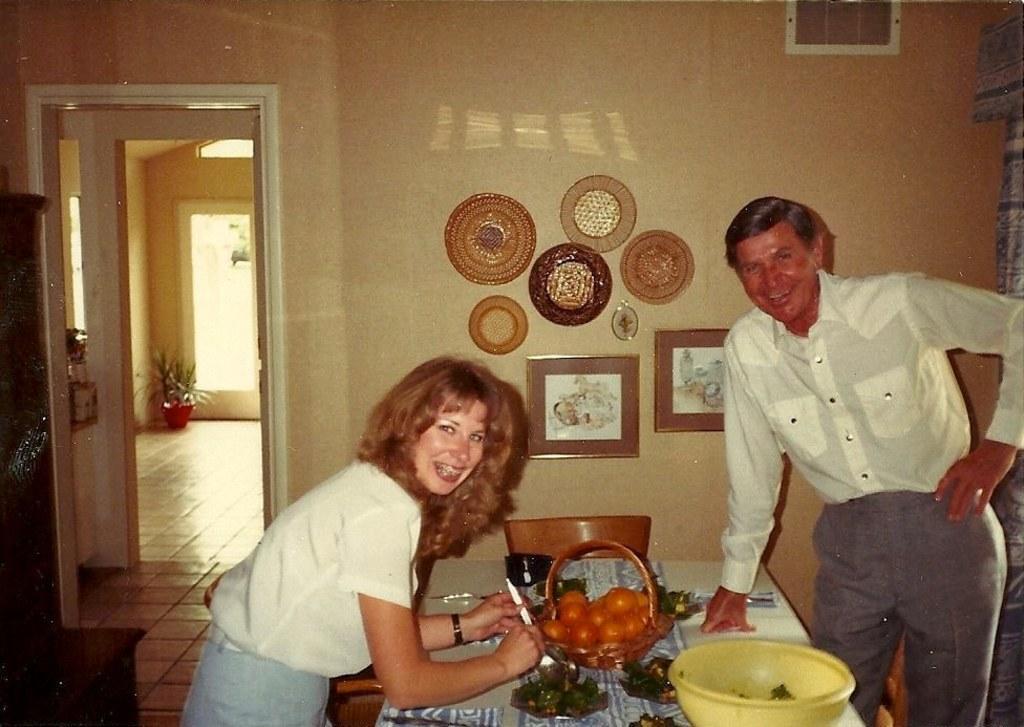Describe this image in one or two sentences. In this picture we can find a man and woman at the table with some chairs and also fruit basket and a bowl, and there are some photo frames on the wall and there is a door at the left side. 